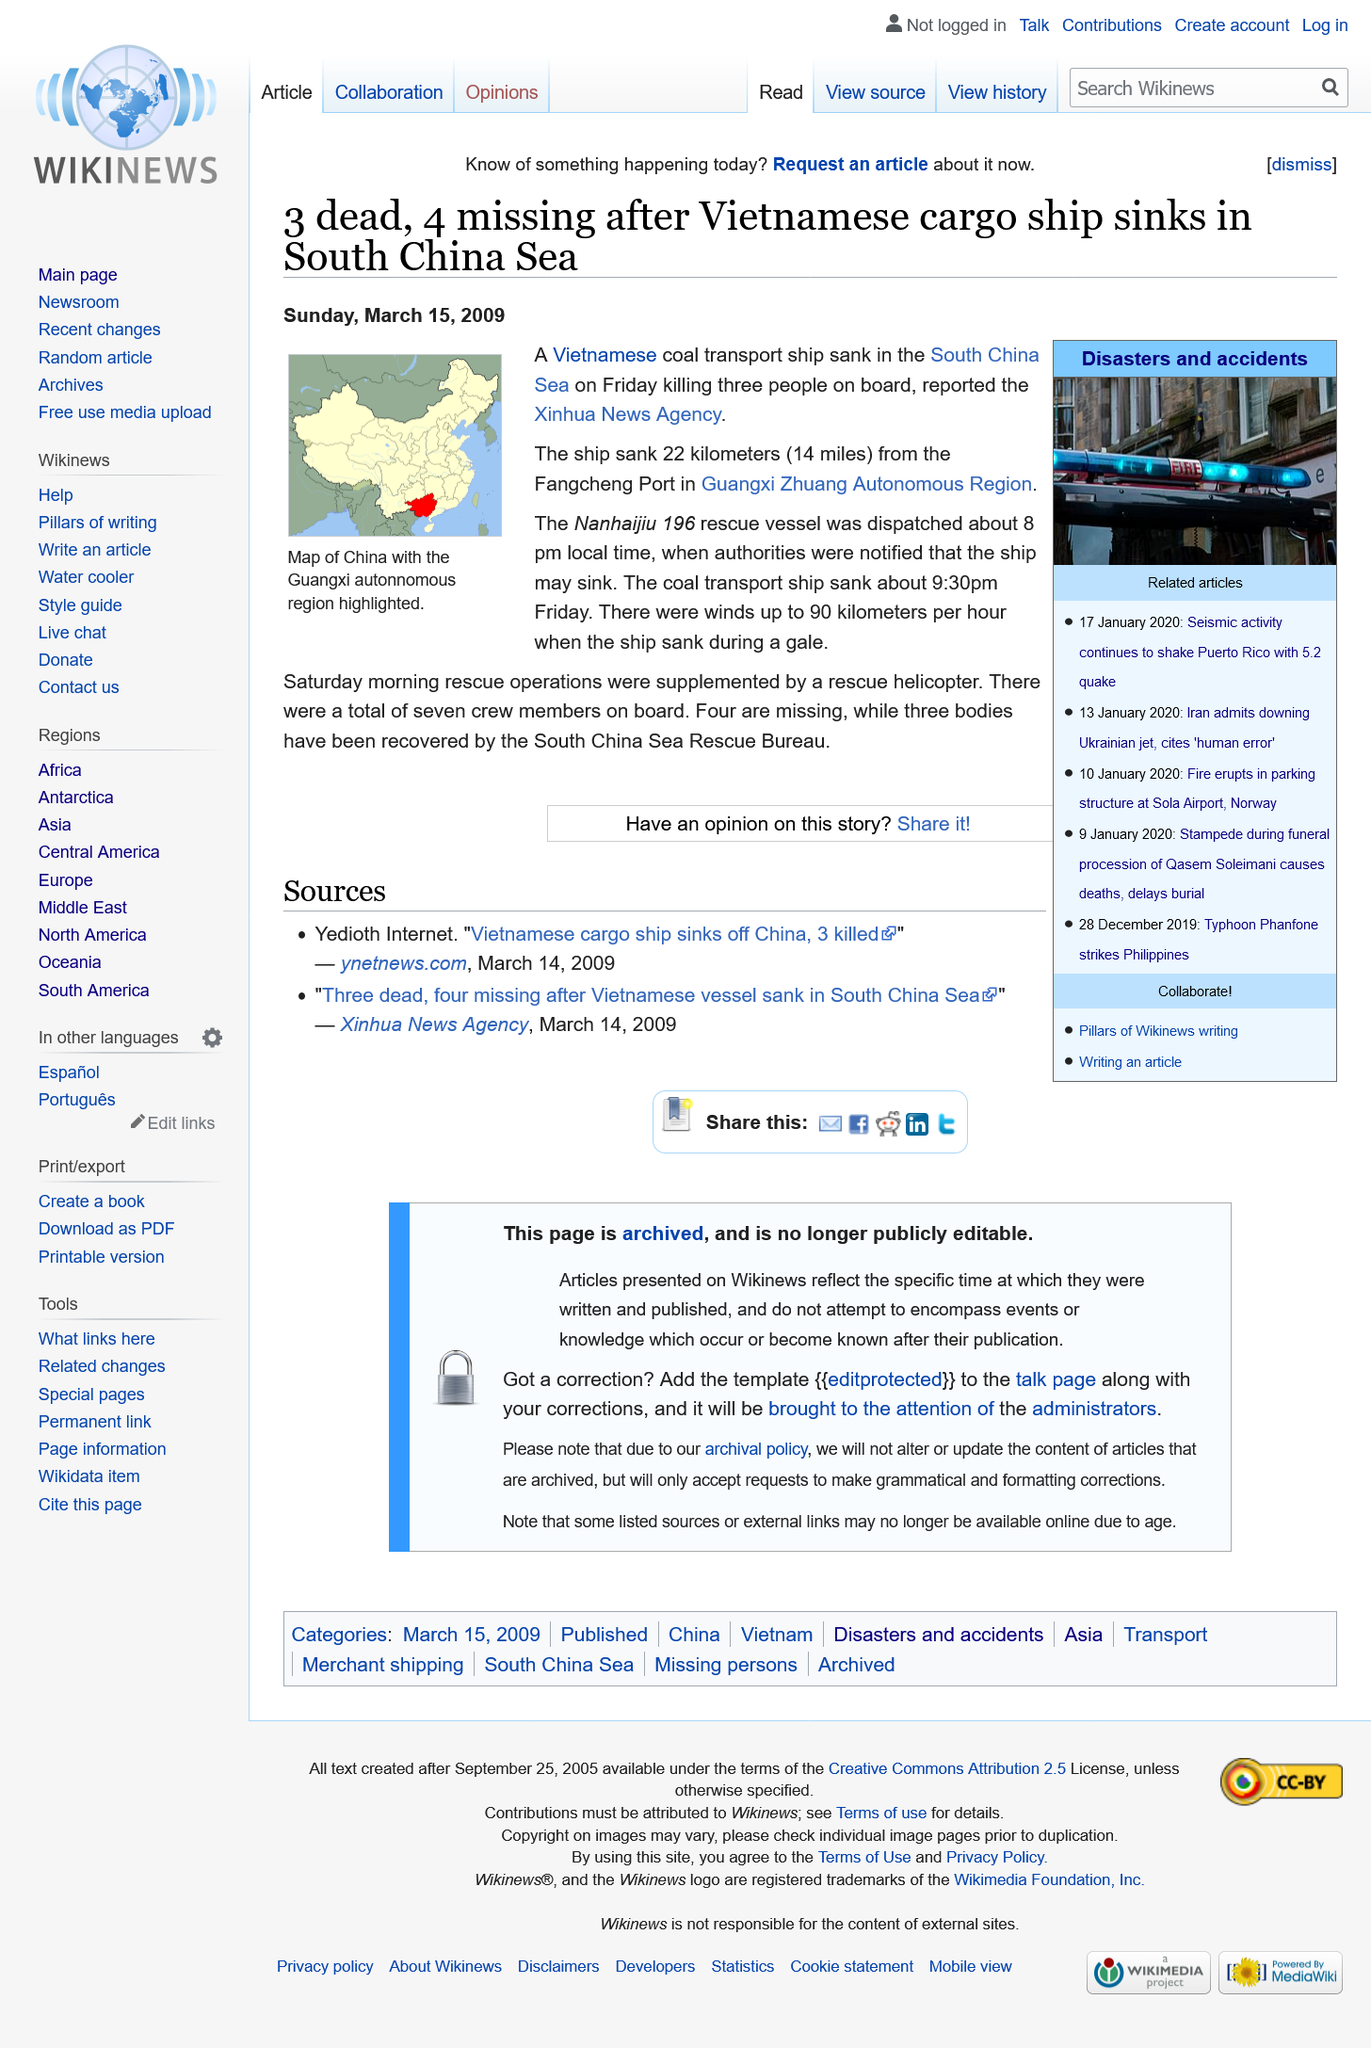Give some essential details in this illustration. The coal transport ship sank in the South China Sea. A total of three individuals were tragically killed on board the ship, and the vessel sank at approximately 9:30pm on Friday evening. The ship sank 22 kilometers (14 miles) away from the Fangcheng Port, and this information provides a valuable insight into the distance from which the ship was sailing when it sank. 